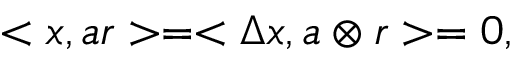<formula> <loc_0><loc_0><loc_500><loc_500>< x , a r > = < \Delta x , a \otimes r > = 0 ,</formula> 